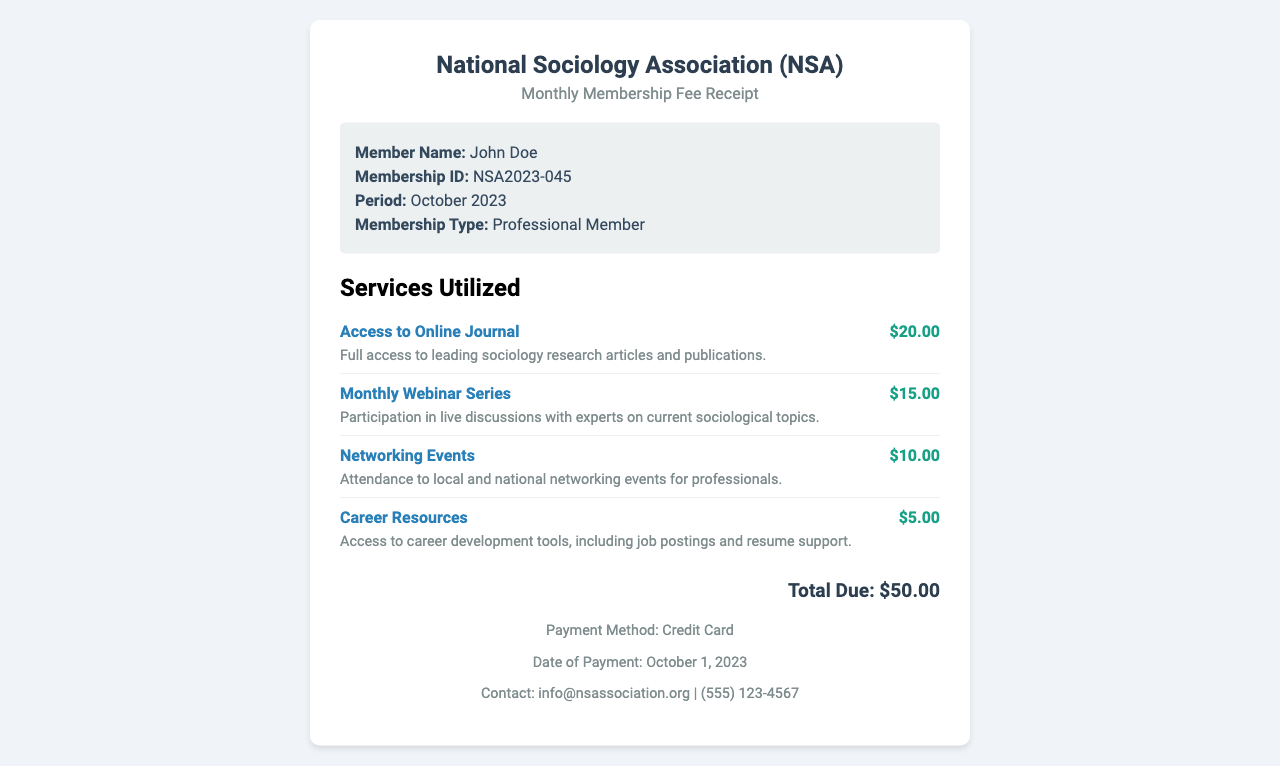What is the name of the member? The member's name is stated in the document under "Member Name."
Answer: John Doe What is the membership ID? The membership ID can be found in the member information section of the document.
Answer: NSA2023-045 What is the total amount due? The total amount due is listed at the bottom of the receipt.
Answer: $50.00 What services were utilized? The services utilized are detailed in the "Services Utilized" section.
Answer: Access to Online Journal, Monthly Webinar Series, Networking Events, Career Resources What is the payment method? The payment method is mentioned in the footer section of the receipt.
Answer: Credit Card What is the cost of the Networking Events service? The cost of the Networking Events service is specified next to the service description.
Answer: $10.00 When was the payment made? The date of payment is listed in the footer of the receipt.
Answer: October 1, 2023 What type of membership does the member have? The type of membership is indicated under "Membership Type" in the member info section.
Answer: Professional Member What is included in the access to online journal service? The description of the access to online journal is mentioned below the service name.
Answer: Full access to leading sociology research articles and publications 